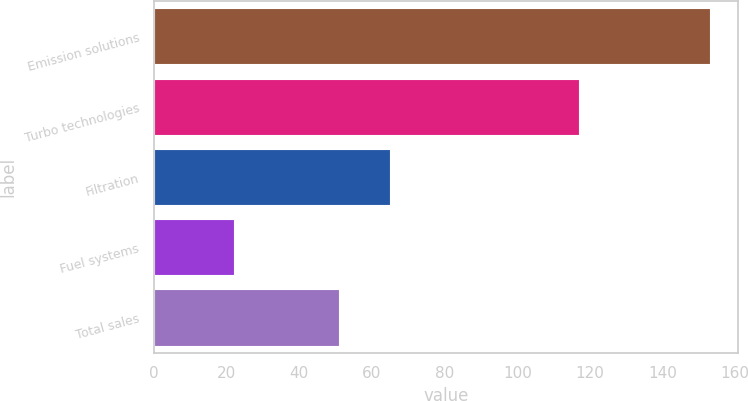Convert chart to OTSL. <chart><loc_0><loc_0><loc_500><loc_500><bar_chart><fcel>Emission solutions<fcel>Turbo technologies<fcel>Filtration<fcel>Fuel systems<fcel>Total sales<nl><fcel>153<fcel>117<fcel>65<fcel>22<fcel>51<nl></chart> 